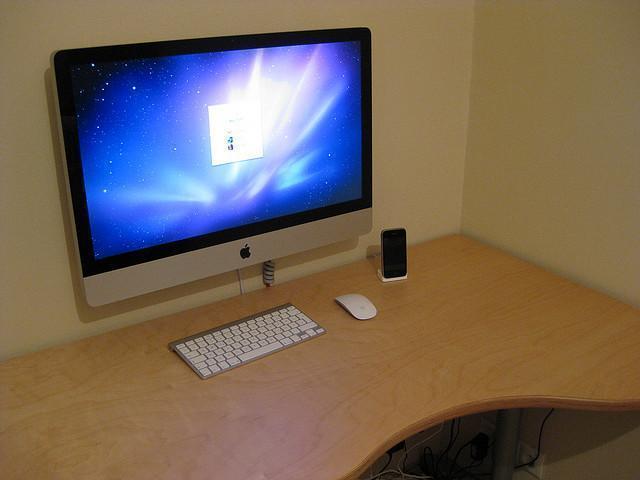What is on the desk?
Pick the right solution, then justify: 'Answer: answer
Rationale: rationale.'
Options: Laptop, stuffed doll, textbook, candy dish. Answer: laptop.
Rationale: The desk has a laptop. 